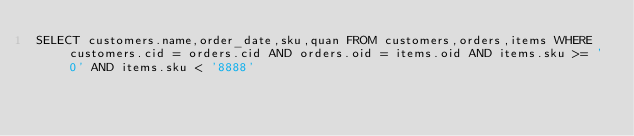<code> <loc_0><loc_0><loc_500><loc_500><_SQL_>SELECT customers.name,order_date,sku,quan FROM customers,orders,items WHERE customers.cid = orders.cid AND orders.oid = items.oid AND items.sku >= '0' AND items.sku < '8888'</code> 